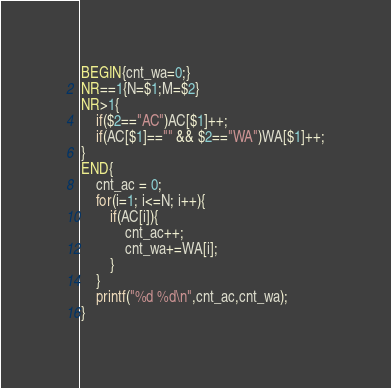<code> <loc_0><loc_0><loc_500><loc_500><_Awk_>BEGIN{cnt_wa=0;}
NR==1{N=$1;M=$2}
NR>1{
    if($2=="AC")AC[$1]++;
    if(AC[$1]=="" && $2=="WA")WA[$1]++;
}
END{
	cnt_ac = 0;
	for(i=1; i<=N; i++){
		if(AC[i]){
        	cnt_ac++;
            cnt_wa+=WA[i];
        }
    }
    printf("%d %d\n",cnt_ac,cnt_wa);
}
</code> 